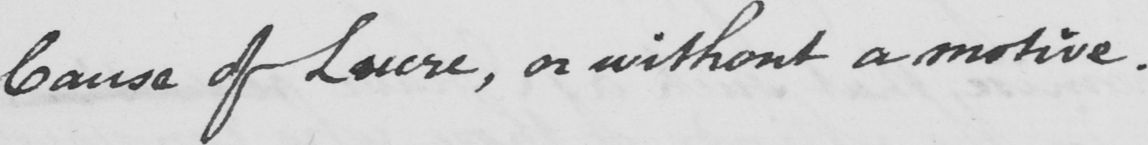Can you read and transcribe this handwriting? Cause of Lucre or , without a motive . 